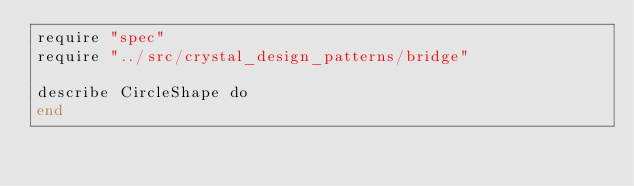<code> <loc_0><loc_0><loc_500><loc_500><_Crystal_>require "spec"
require "../src/crystal_design_patterns/bridge"

describe CircleShape do
end
</code> 